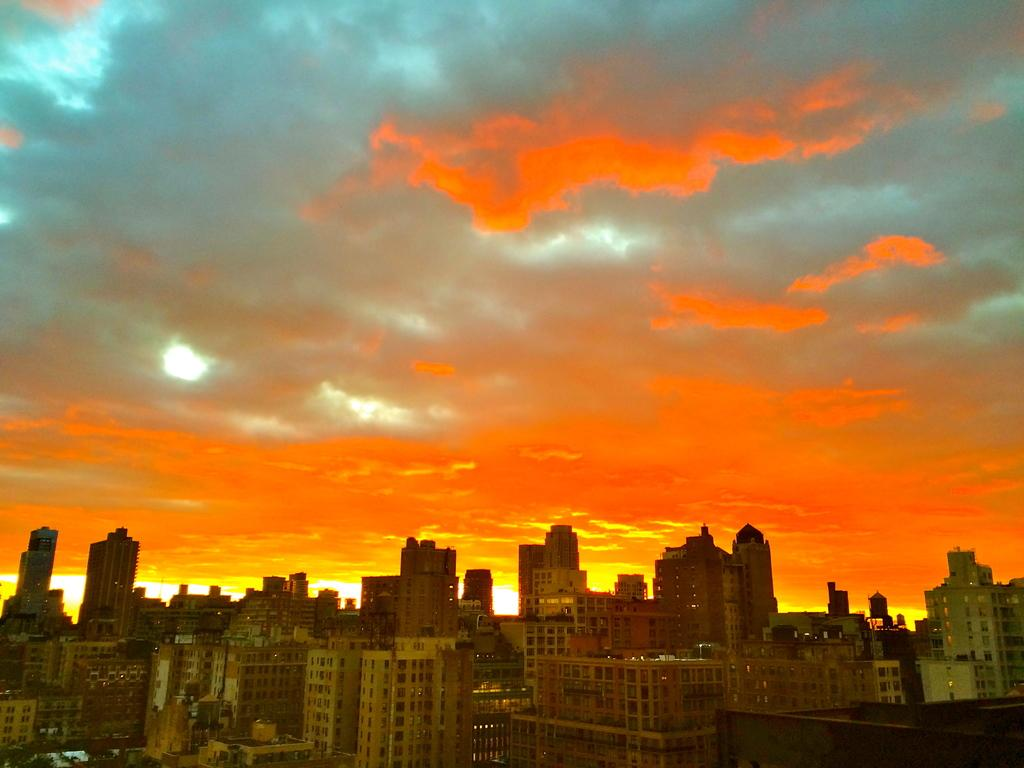What structures are present in the image? There are buildings in the image. What can be seen in the background of the image? The sky is visible in the background of the image. What type of toothbrush is hanging on the building in the image? There is no toothbrush present in the image; it only features buildings and the sky in the background. 